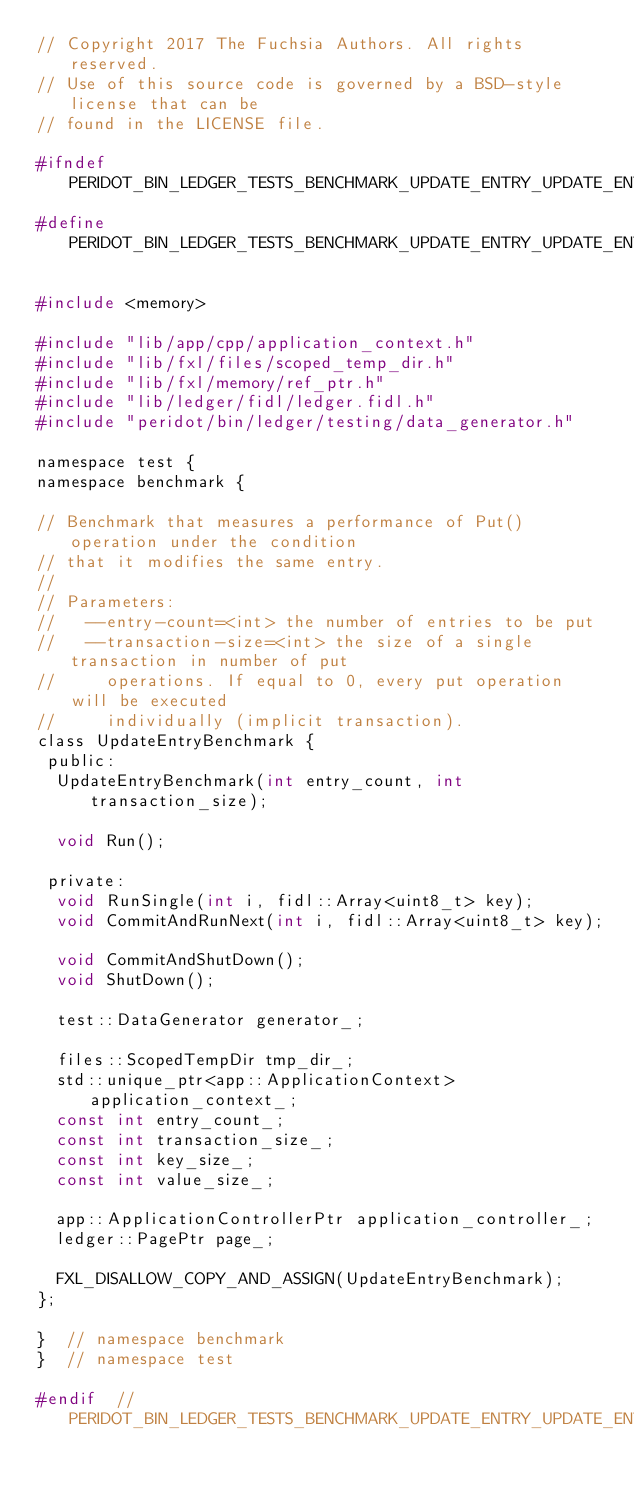Convert code to text. <code><loc_0><loc_0><loc_500><loc_500><_C_>// Copyright 2017 The Fuchsia Authors. All rights reserved.
// Use of this source code is governed by a BSD-style license that can be
// found in the LICENSE file.

#ifndef PERIDOT_BIN_LEDGER_TESTS_BENCHMARK_UPDATE_ENTRY_UPDATE_ENTRY_H_
#define PERIDOT_BIN_LEDGER_TESTS_BENCHMARK_UPDATE_ENTRY_UPDATE_ENTRY_H_

#include <memory>

#include "lib/app/cpp/application_context.h"
#include "lib/fxl/files/scoped_temp_dir.h"
#include "lib/fxl/memory/ref_ptr.h"
#include "lib/ledger/fidl/ledger.fidl.h"
#include "peridot/bin/ledger/testing/data_generator.h"

namespace test {
namespace benchmark {

// Benchmark that measures a performance of Put() operation under the condition
// that it modifies the same entry.
//
// Parameters:
//   --entry-count=<int> the number of entries to be put
//   --transaction-size=<int> the size of a single transaction in number of put
//     operations. If equal to 0, every put operation will be executed
//     individually (implicit transaction).
class UpdateEntryBenchmark {
 public:
  UpdateEntryBenchmark(int entry_count, int transaction_size);

  void Run();

 private:
  void RunSingle(int i, fidl::Array<uint8_t> key);
  void CommitAndRunNext(int i, fidl::Array<uint8_t> key);

  void CommitAndShutDown();
  void ShutDown();

  test::DataGenerator generator_;

  files::ScopedTempDir tmp_dir_;
  std::unique_ptr<app::ApplicationContext> application_context_;
  const int entry_count_;
  const int transaction_size_;
  const int key_size_;
  const int value_size_;

  app::ApplicationControllerPtr application_controller_;
  ledger::PagePtr page_;

  FXL_DISALLOW_COPY_AND_ASSIGN(UpdateEntryBenchmark);
};

}  // namespace benchmark
}  // namespace test

#endif  // PERIDOT_BIN_LEDGER_TESTS_BENCHMARK_UPDATE_ENTRY_UPDATE_ENTRY_H_
</code> 